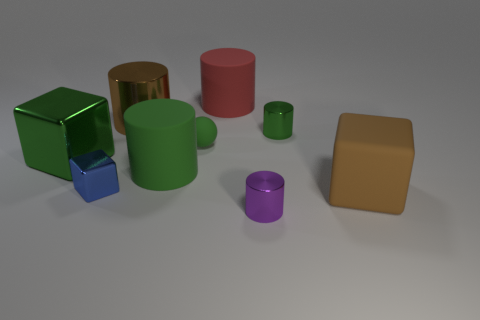Are there any other things that are made of the same material as the large red cylinder?
Make the answer very short. Yes. How many other objects are the same color as the tiny rubber thing?
Your answer should be compact. 3. Does the tiny rubber sphere have the same color as the big metal cylinder?
Keep it short and to the point. No. What is the color of the big cylinder that is both in front of the big red matte cylinder and behind the big green metal block?
Keep it short and to the point. Brown. Is the material of the large brown cylinder the same as the small blue block?
Provide a succinct answer. Yes. The large green matte object is what shape?
Provide a short and direct response. Cylinder. How many big rubber cylinders are on the right side of the cylinder that is to the right of the small shiny object in front of the large brown block?
Your response must be concise. 0. What is the color of the other tiny thing that is the same shape as the tiny purple shiny object?
Ensure brevity in your answer.  Green. There is a brown object right of the brown thing that is behind the big brown thing that is on the right side of the purple cylinder; what is its shape?
Provide a succinct answer. Cube. There is a block that is both on the left side of the brown matte object and right of the green shiny cube; how big is it?
Provide a short and direct response. Small. 